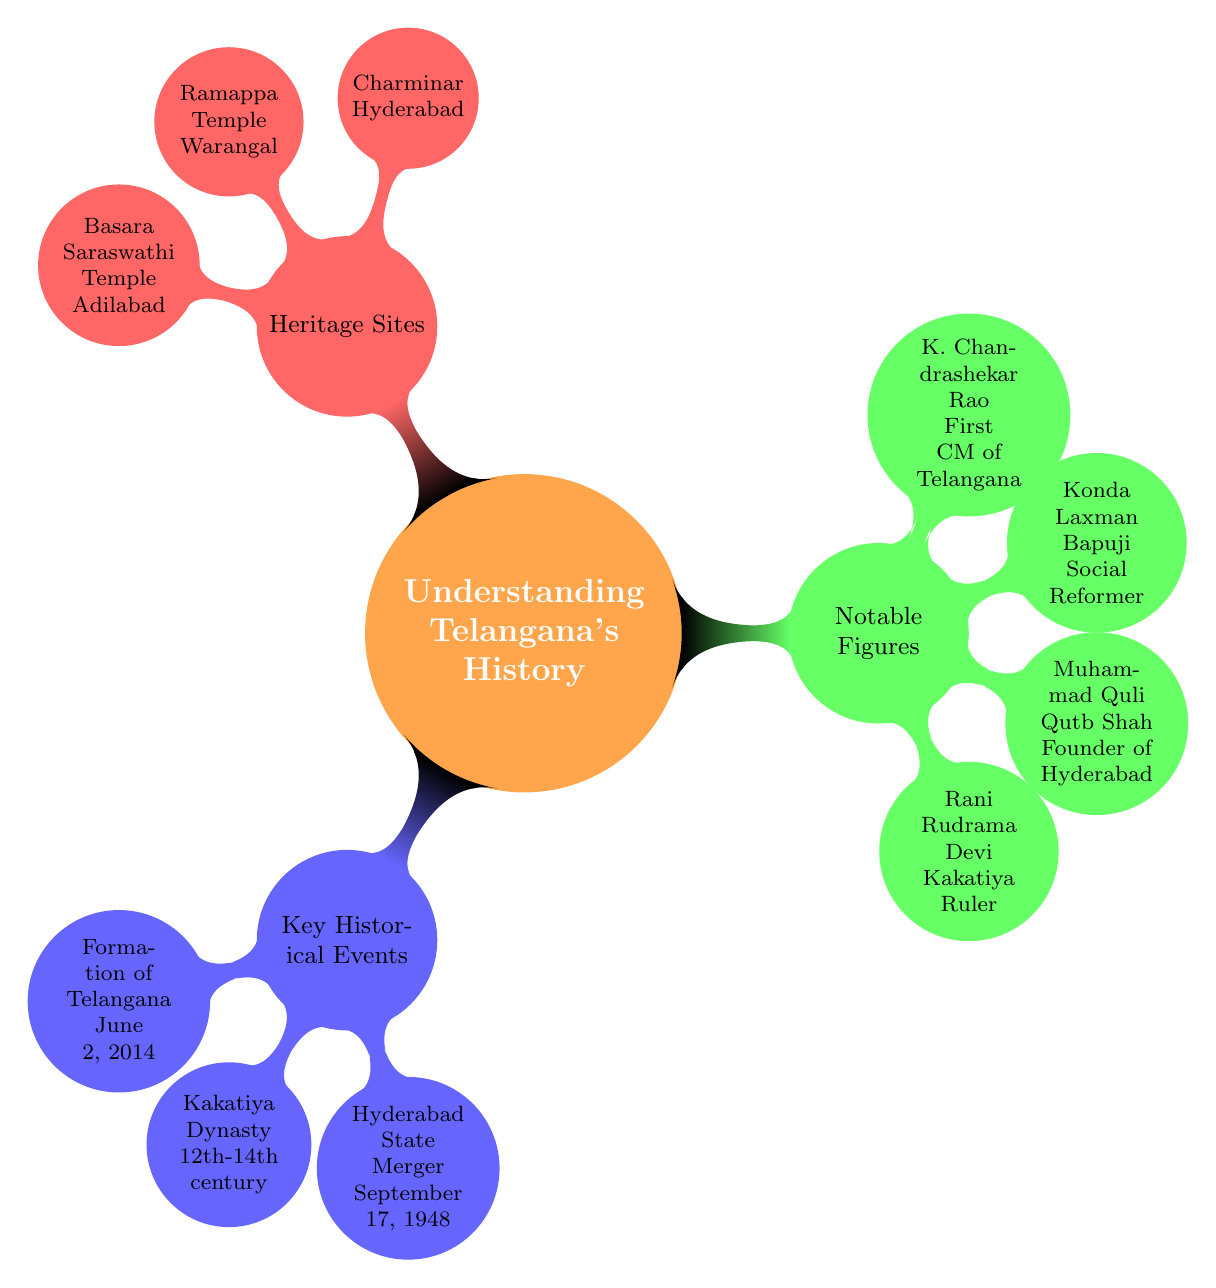What is the formation date of Telangana? The diagram lists "Formation of Telangana" under "Key Historical Events" and specifies the date as "June 2, 2014."
Answer: June 2, 2014 Who was the founder of Hyderabad? The diagram identifies "Founder of Hyderabad" under "Notable Figures" as "Muhammad Quli Qutb Shah."
Answer: Muhammad Quli Qutb Shah Which famous heritage site is located in Warangal? Under "Heritage Sites," the node states that "Ramappa Temple" is located in "Warangal."
Answer: Ramappa Temple How many notable figures are mentioned in the diagram? The "Notable Figures" node contains 4 child nodes, each representing a significant person, which indicates there are four notable figures.
Answer: 4 What historical event occurred on September 17, 1948? The diagram shows "Hyderabad State Merger" as one of the "Key Historical Events" with the date "September 17, 1948" written next to it.
Answer: Hyderabad State Merger Which city is the Charminar located in? The diagram mentions "Charminar" under "Heritage Sites," indicating it is in "Hyderabad."
Answer: Hyderabad What is the role of K. Chandrashekar Rao in Telangana's history? "K. Chandrashekar Rao" is listed as "First CM of Telangana" in the "Notable Figures" section.
Answer: First CM of Telangana What era did the Kakatiya Dynasty encompass? The diagram states that the "Kakatiya Dynasty" existed from the "12th to 14th century" in the "Key Historical Events" section.
Answer: 12th to 14th century 